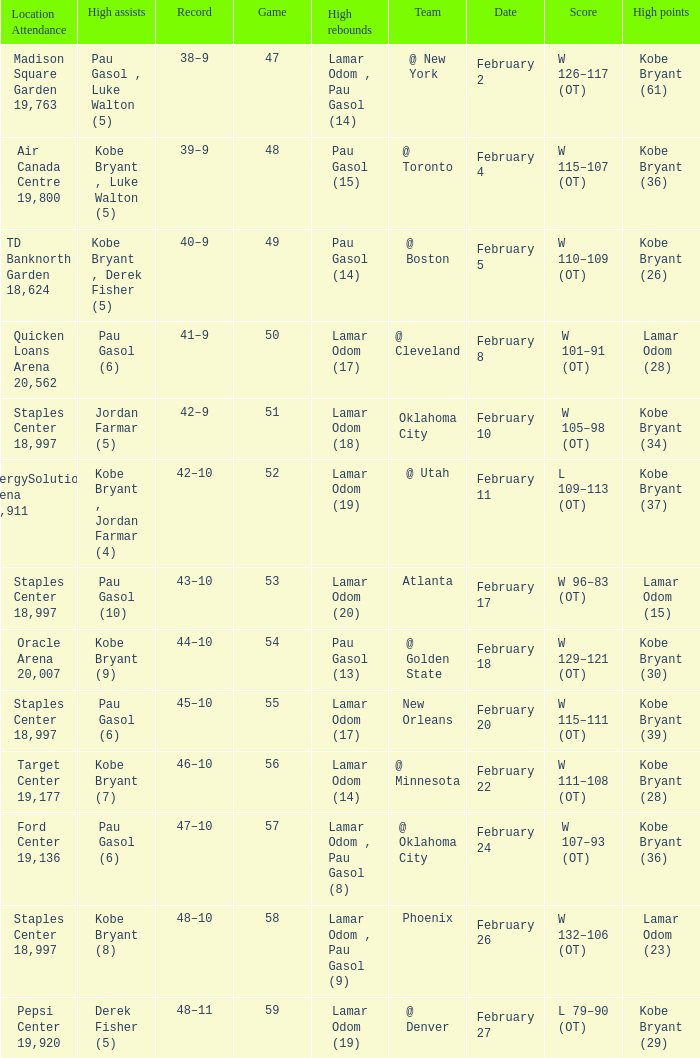Who had the most assists in the game against Atlanta? Pau Gasol (10). 